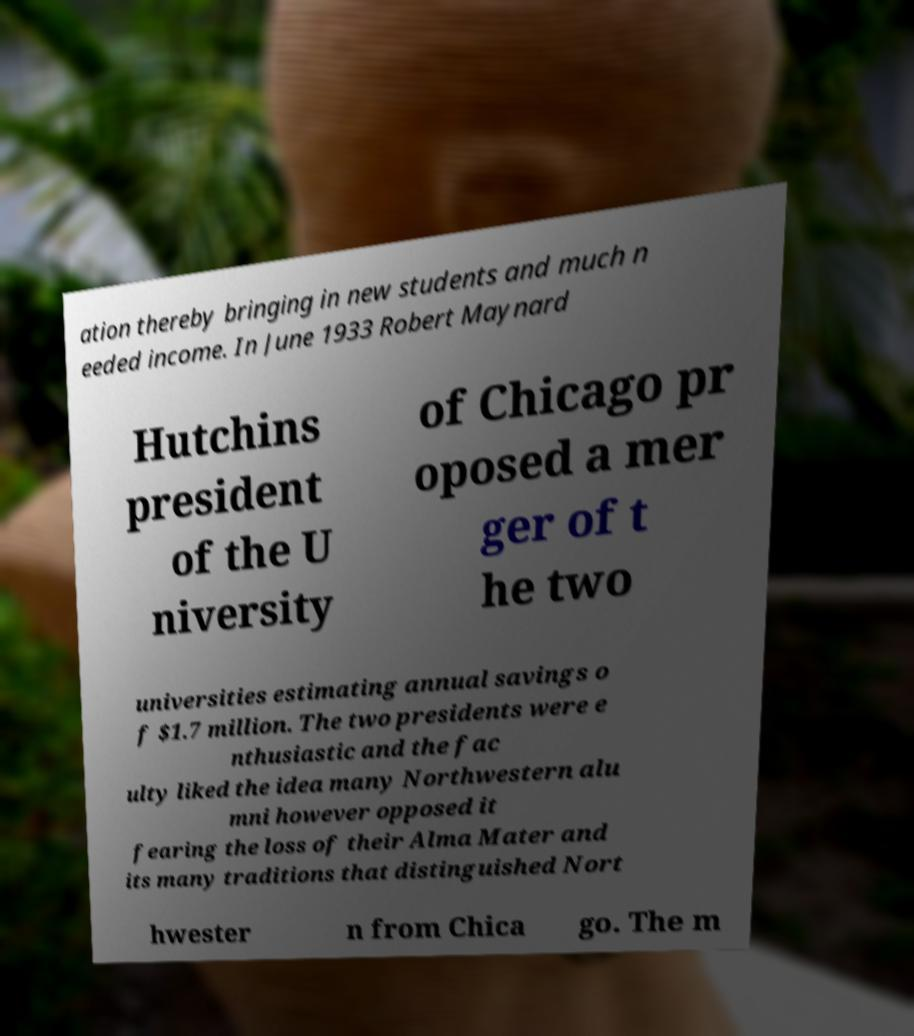For documentation purposes, I need the text within this image transcribed. Could you provide that? ation thereby bringing in new students and much n eeded income. In June 1933 Robert Maynard Hutchins president of the U niversity of Chicago pr oposed a mer ger of t he two universities estimating annual savings o f $1.7 million. The two presidents were e nthusiastic and the fac ulty liked the idea many Northwestern alu mni however opposed it fearing the loss of their Alma Mater and its many traditions that distinguished Nort hwester n from Chica go. The m 